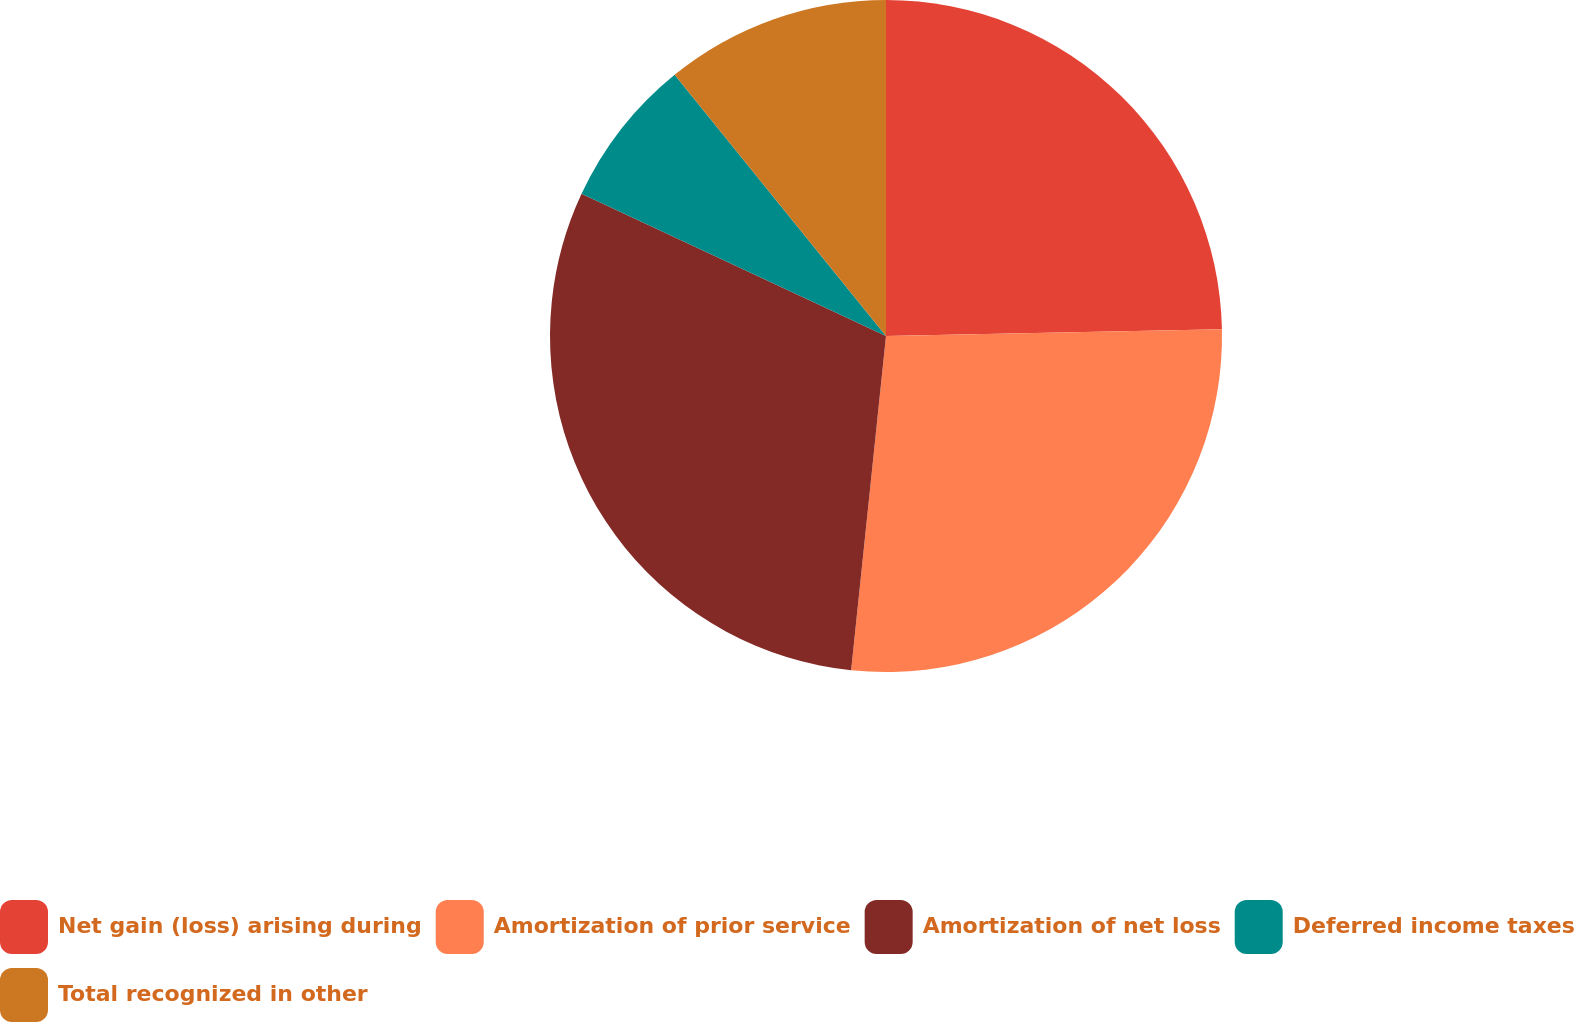<chart> <loc_0><loc_0><loc_500><loc_500><pie_chart><fcel>Net gain (loss) arising during<fcel>Amortization of prior service<fcel>Amortization of net loss<fcel>Deferred income taxes<fcel>Total recognized in other<nl><fcel>24.68%<fcel>26.98%<fcel>30.3%<fcel>7.22%<fcel>10.83%<nl></chart> 